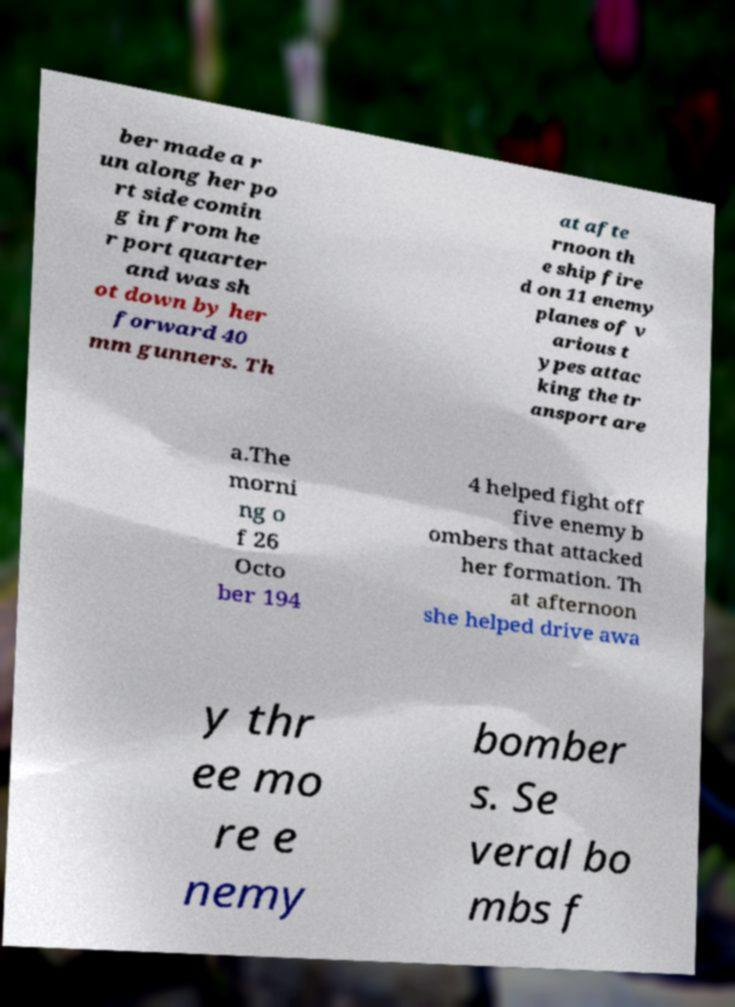Please read and relay the text visible in this image. What does it say? ber made a r un along her po rt side comin g in from he r port quarter and was sh ot down by her forward 40 mm gunners. Th at afte rnoon th e ship fire d on 11 enemy planes of v arious t ypes attac king the tr ansport are a.The morni ng o f 26 Octo ber 194 4 helped fight off five enemy b ombers that attacked her formation. Th at afternoon she helped drive awa y thr ee mo re e nemy bomber s. Se veral bo mbs f 